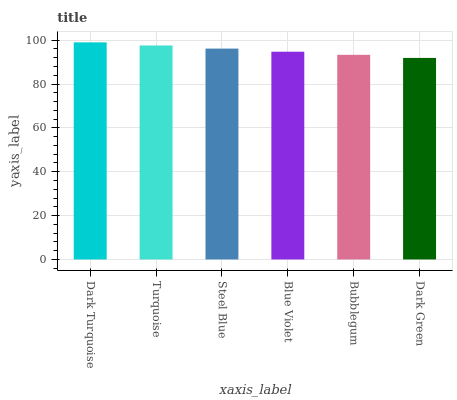Is Turquoise the minimum?
Answer yes or no. No. Is Turquoise the maximum?
Answer yes or no. No. Is Dark Turquoise greater than Turquoise?
Answer yes or no. Yes. Is Turquoise less than Dark Turquoise?
Answer yes or no. Yes. Is Turquoise greater than Dark Turquoise?
Answer yes or no. No. Is Dark Turquoise less than Turquoise?
Answer yes or no. No. Is Steel Blue the high median?
Answer yes or no. Yes. Is Blue Violet the low median?
Answer yes or no. Yes. Is Dark Green the high median?
Answer yes or no. No. Is Dark Green the low median?
Answer yes or no. No. 